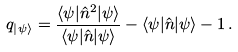<formula> <loc_0><loc_0><loc_500><loc_500>q _ { \left | \psi \right \rangle } = \frac { \langle \psi | \hat { n } ^ { 2 } | \psi \rangle } { \langle \psi | \hat { n } | \psi \rangle } - \langle \psi | \hat { n } | \psi \rangle - 1 \, .</formula> 